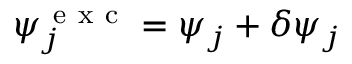<formula> <loc_0><loc_0><loc_500><loc_500>\psi _ { j } ^ { e x c } = \psi _ { j } + \delta \psi _ { j }</formula> 